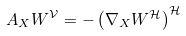<formula> <loc_0><loc_0><loc_500><loc_500>A _ { X } W ^ { \mathcal { V } } = - \left ( \nabla _ { X } W ^ { \mathcal { H } } \right ) ^ { \mathcal { H } }</formula> 